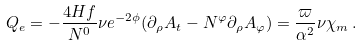Convert formula to latex. <formula><loc_0><loc_0><loc_500><loc_500>Q _ { e } = - \frac { 4 H f } { N ^ { 0 } } \nu e ^ { - 2 \phi } ( \partial _ { \rho } A _ { t } - N ^ { \varphi } \partial _ { \rho } A _ { \varphi } ) = \frac { \varpi } { \alpha ^ { 2 } } \nu \chi _ { m } \, .</formula> 